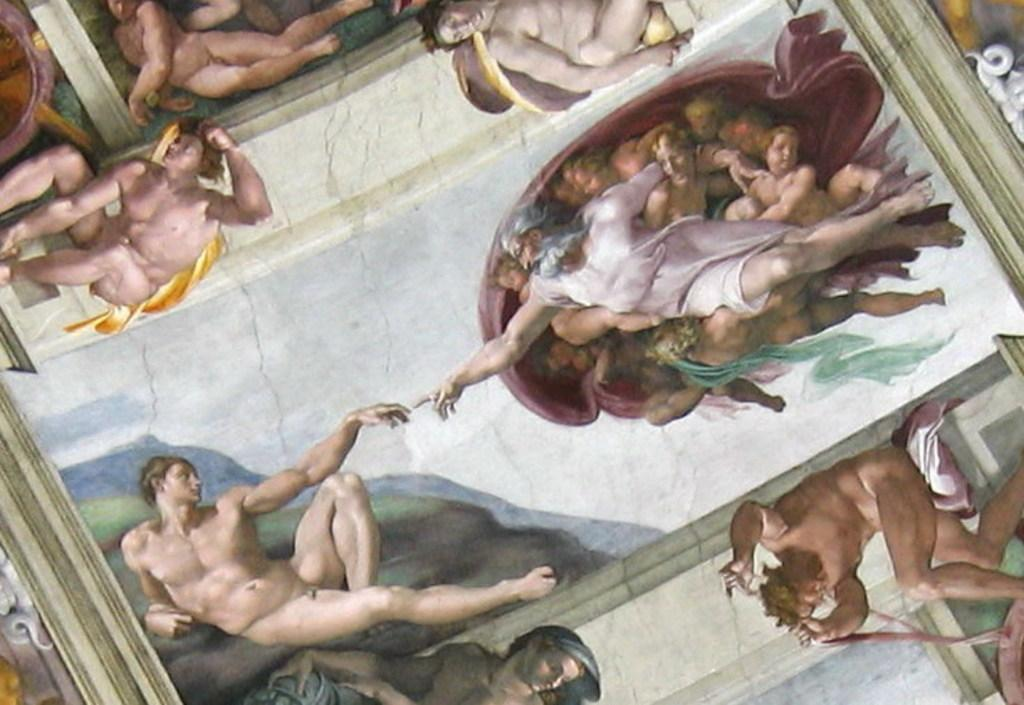What type of artwork is shown in the image? The image appears to be a painting. What subjects are depicted in the painting? There are people depicted in the painting. What type of landscape feature is present in the painting? There is a hill in the painting. What type of object is visible in the painting? There is a cloth visible in the painting. How does the stone help the person in the painting to grip the kick? There is no stone or kick present in the painting; it only features people, a hill, and a cloth. 